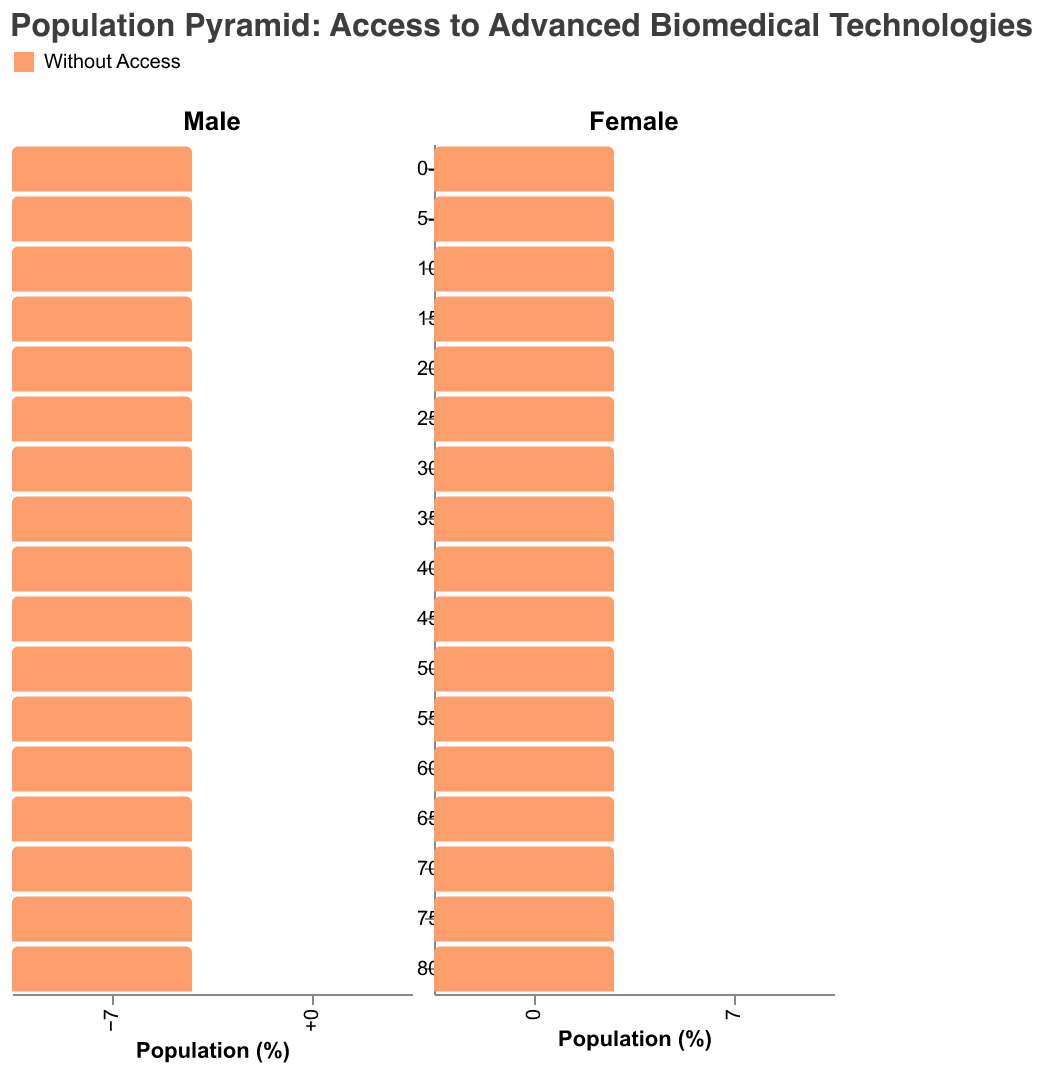What's the title of the figure? The title of the figure is located at the top and usually describes the overall content of the chart. Here, it specifies the focus on population comparison based on access to advanced biomedical technologies.
Answer: Population Pyramid: Access to Advanced Biomedical Technologies Which age group has the highest percentage of males without access to advanced biomedical technologies? To determine this, look for the largest bar on the left side of the figure representing males without access.
Answer: 80+ In the age group 30-34, which population percentage is higher: males with access or females with access? Compare the lengths of the bars for males and females within the 30-34 age group on the right side of the figure representing those with access.
Answer: Males with access What's the difference in percentage between females without access and females with access in the 45-49 age group? Subtract the percentage of females with access from the percentage of females without access within the 45-49 age group.
Answer: 0.7% In which age group is the gap between populations with and without access to advanced biomedical technologies the smallest for males? Calculate the difference between the percentages of males with and without access for each age group and identify the smallest difference.
Answer: 0-4 How does the population structure differ between those with access and those without access for the age group 55-59? Compare the bar lengths for the 55-59 age group for both the with access and without access categories for both genders, noting which side is longer.
Answer: Without access has higher percentages for both genders What trends can be observed for populations with access to advanced biomedical technologies as age increases? Observe the general pattern of bar lengths across age groups to determine if there is an increase, decrease, or a consistent pattern.
Answer: Increasing What's the average population percentage for females with access to advanced biomedical technologies across all age groups? To find the average, sum the percentages of females with access in all age groups and divide by the number of age groups (17).
Answer: 4.39% Comparing the age groups 65-69 and 70-74, which has a higher percentage gap between males with access and males without access? Calculate the difference in percentages for males with and without access for both age groups and compare the two gaps.
Answer: 70-74 (0.7% vs 0.9%) In which age group is the percentage of females with access closest to the percentage of females without access? Find the age group where the difference between the percentages of females with and without access is the smallest.
Answer: 0-4 